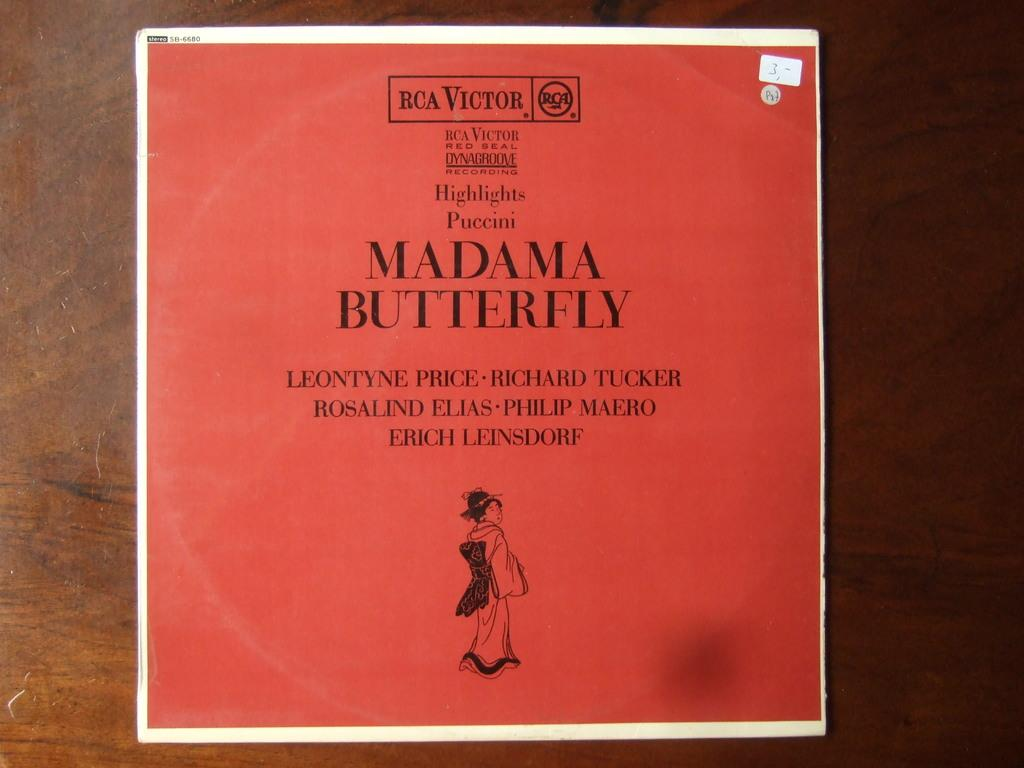<image>
Give a short and clear explanation of the subsequent image. An album by RCA Victor of Madame Butterfly. 